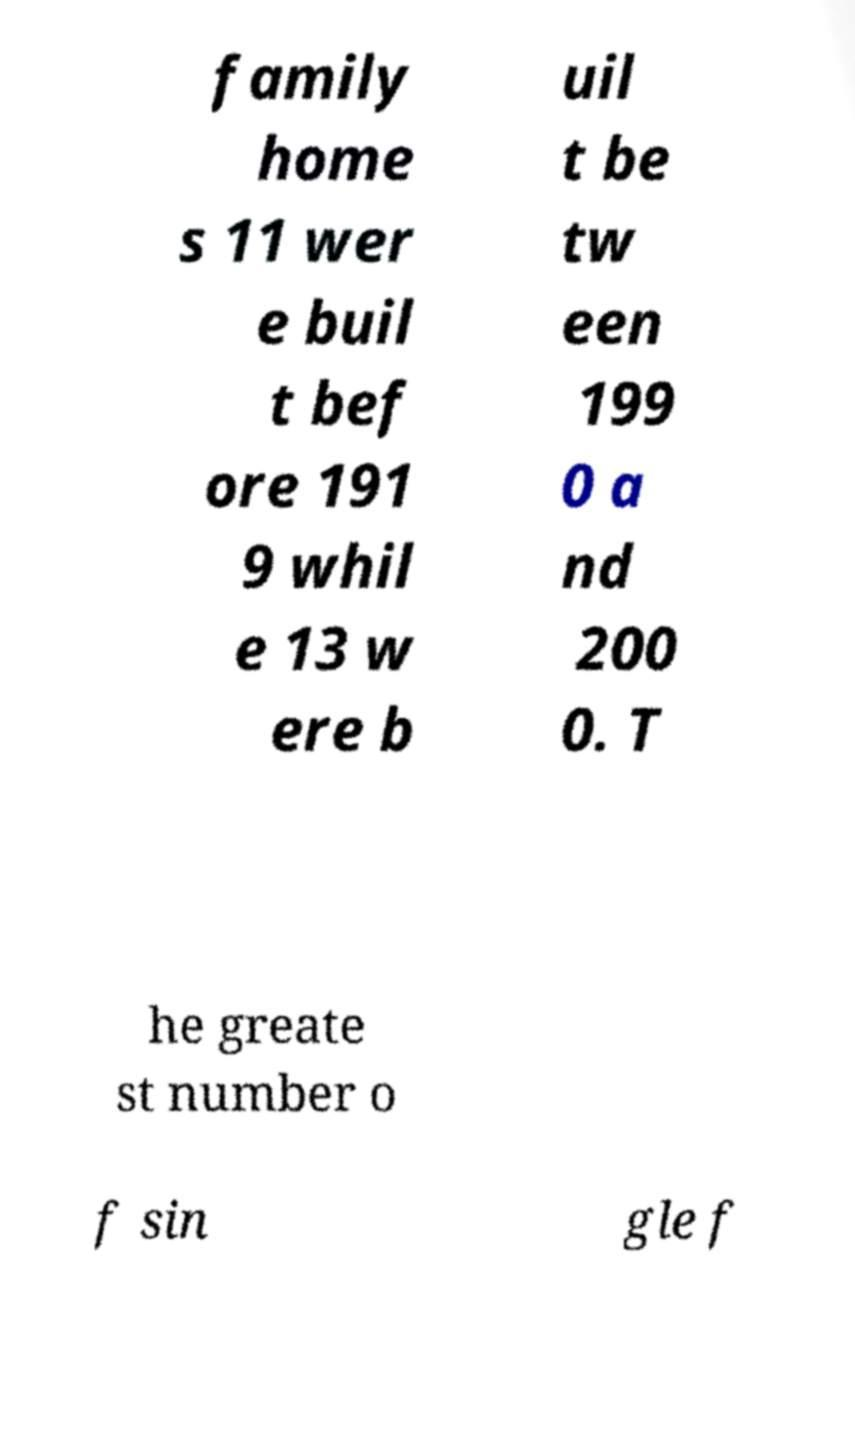Could you extract and type out the text from this image? family home s 11 wer e buil t bef ore 191 9 whil e 13 w ere b uil t be tw een 199 0 a nd 200 0. T he greate st number o f sin gle f 